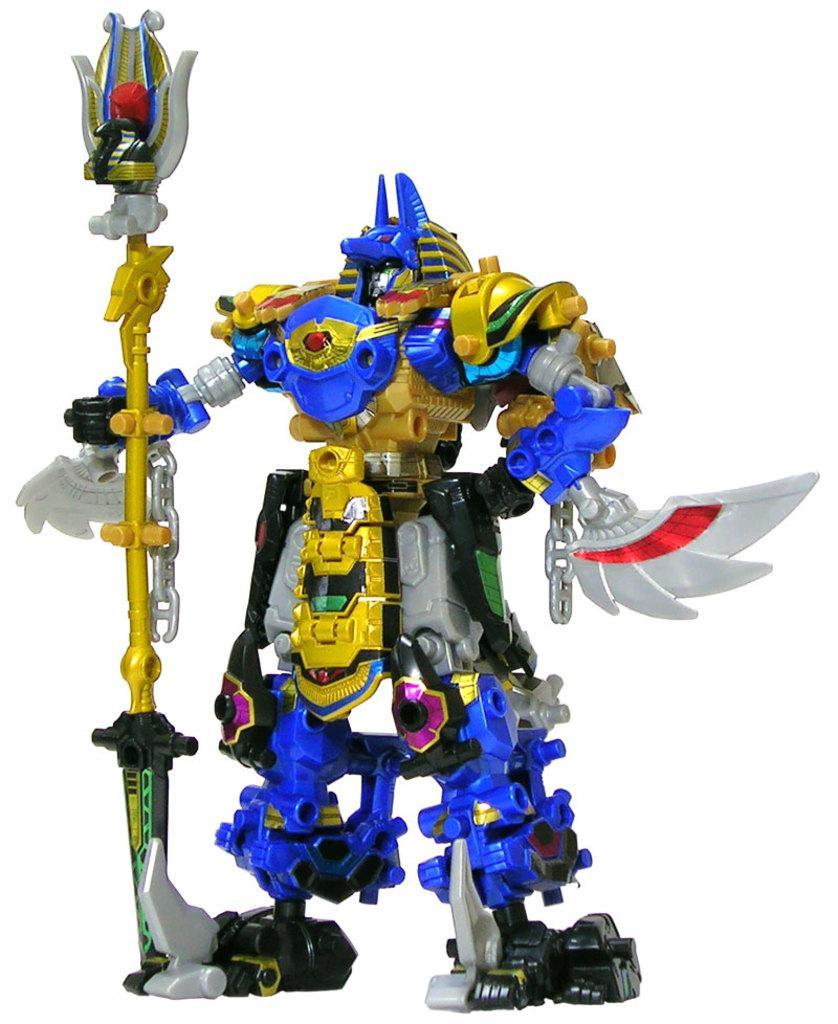Could you give a brief overview of what you see in this image? In this picture there is a toy holding an object in its hand. 